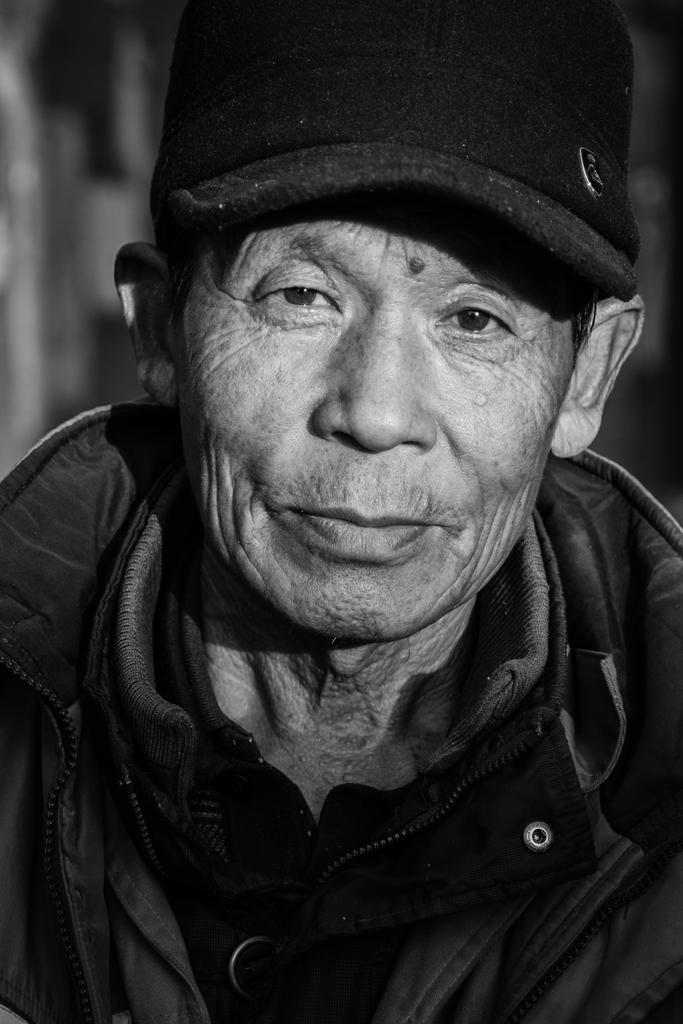What is the color scheme of the image? The image is black and white. Can you describe the main subject in the image? There is a person in the image. What is the person wearing on their head? The person is wearing a cap. How many appliances can be seen in the image? There are no appliances present in the image. What type of skate is the person using in the image? There is no skate present in the image. 